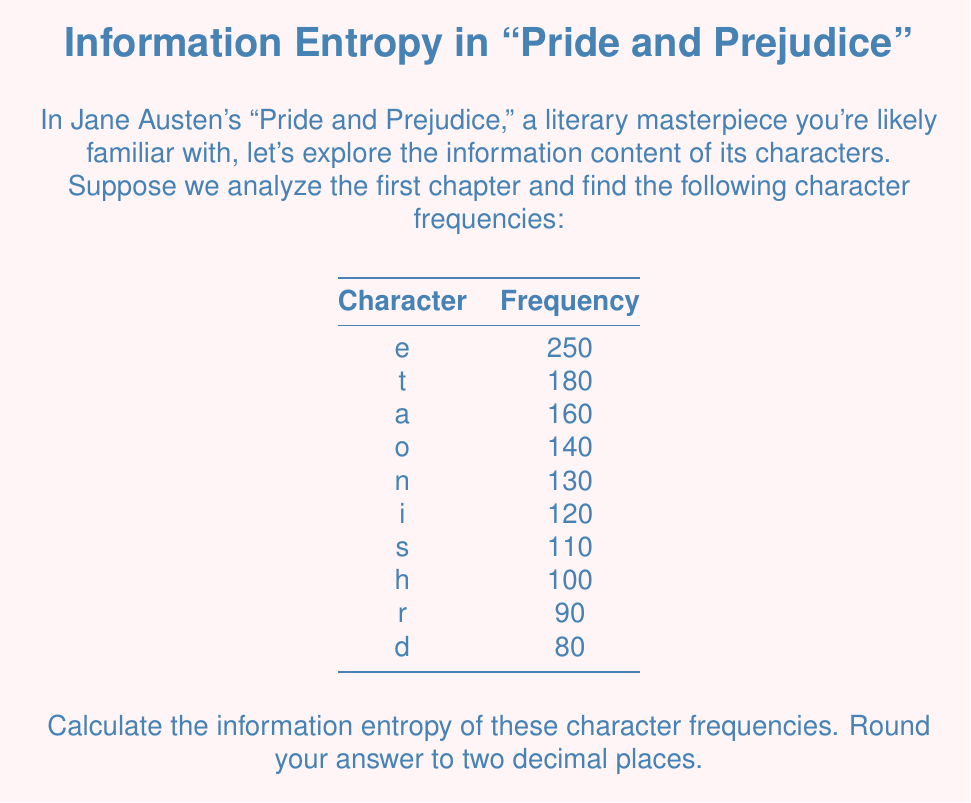Provide a solution to this math problem. To calculate the information entropy, we'll follow these steps:

1. Calculate the total number of characters:
   $N = 250 + 180 + 160 + 140 + 130 + 120 + 110 + 100 + 90 + 80 = 1360$

2. Calculate the probability of each character:
   $p(e) = 250/1360 = 0.1838$
   $p(t) = 180/1360 = 0.1324$
   $p(a) = 160/1360 = 0.1176$
   $p(o) = 140/1360 = 0.1029$
   $p(n) = 130/1360 = 0.0956$
   $p(i) = 120/1360 = 0.0882$
   $p(s) = 110/1360 = 0.0809$
   $p(h) = 100/1360 = 0.0735$
   $p(r) = 90/1360 = 0.0662$
   $p(d) = 80/1360 = 0.0588$

3. Apply the entropy formula:
   $$H = -\sum_{i} p(i) \log_2 p(i)$$

4. Calculate each term:
   $-0.1838 \log_2(0.1838) = 0.4472$
   $-0.1324 \log_2(0.1324) = 0.3870$
   $-0.1176 \log_2(0.1176) = 0.3627$
   $-0.1029 \log_2(0.1029) = 0.3343$
   $-0.0956 \log_2(0.0956) = 0.3204$
   $-0.0882 \log_2(0.0882) = 0.3057$
   $-0.0809 \log_2(0.0809) = 0.2902$
   $-0.0735 \log_2(0.0735) = 0.2738$
   $-0.0662 \log_2(0.0662) = 0.2566$
   $-0.0588 \log_2(0.0588) = 0.2385$

5. Sum all terms:
   $H = 3.2164$ bits

6. Round to two decimal places:
   $H \approx 3.22$ bits
Answer: 3.22 bits 